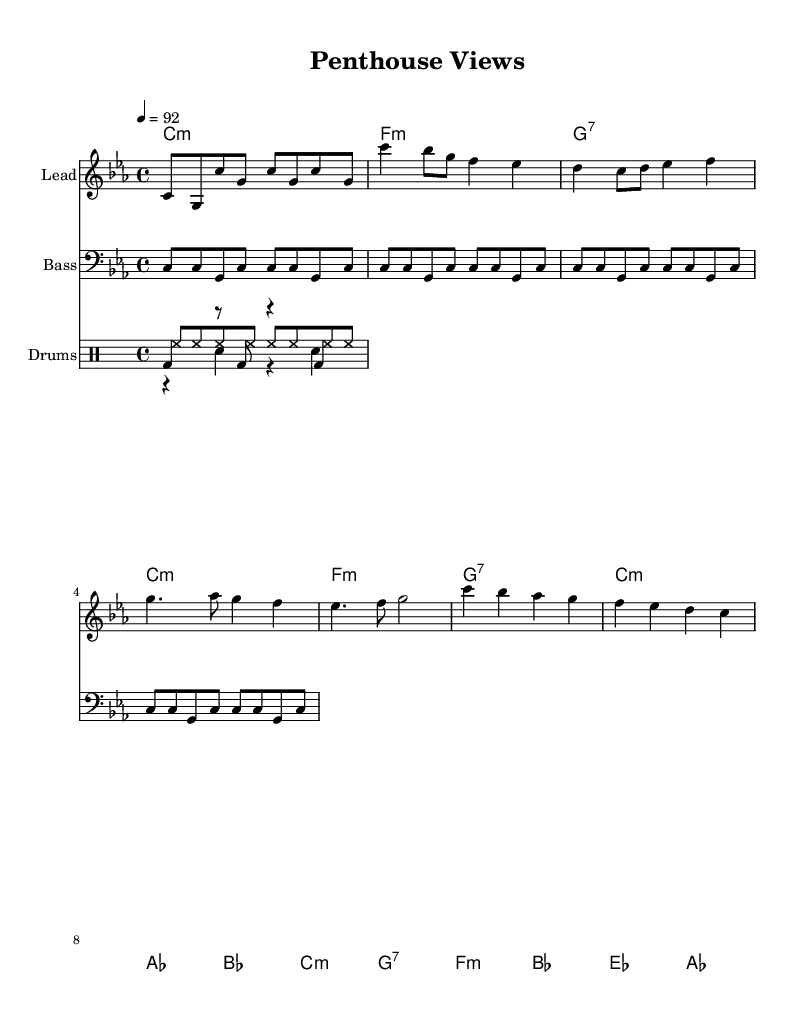What is the key signature of this music? The key signature indicates C minor, which has three flats (B flat, E flat, and A flat). This is found at the beginning of the sheet music.
Answer: C minor What is the time signature of this music? The time signature, visible as a fraction at the beginning, shows 4 over 4, meaning there are four beats in each measure and the quarter note gets one beat.
Answer: 4/4 What is the tempo marking for this piece? The tempo is indicated by “4 = 92” at the beginning, meaning the piece should be played at a quarter note speed of 92 beats per minute.
Answer: 92 How many measures are in the chorus section? By counting the measures in the chorus, which are the lines that specifically repeat the main theme, there are 4 measures identified in that section.
Answer: 4 What type of chord is used in the first measure? The first measure shows a C minor chord, which is deduced from the chord mode at the beginning of the score, specifically written as "c1:m."
Answer: C minor What is the primary rhythm of the kick pattern? Analyzing the kick pattern shows a repeating rhythm primarily consisting of a quarter note kick followed by a rest and another kick, giving a steady beat. This can be observed in the drum pattern section.
Answer: bd4 How many unique sections are present in the composition? By delineating the sections visible in the sheet music, they include the Intro, Verse, Chorus, and Bridge, leading to a total of 4 distinct sections throughout the piece.
Answer: 4 